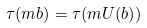<formula> <loc_0><loc_0><loc_500><loc_500>\tau ( m b ) = \tau ( m U ( b ) )</formula> 